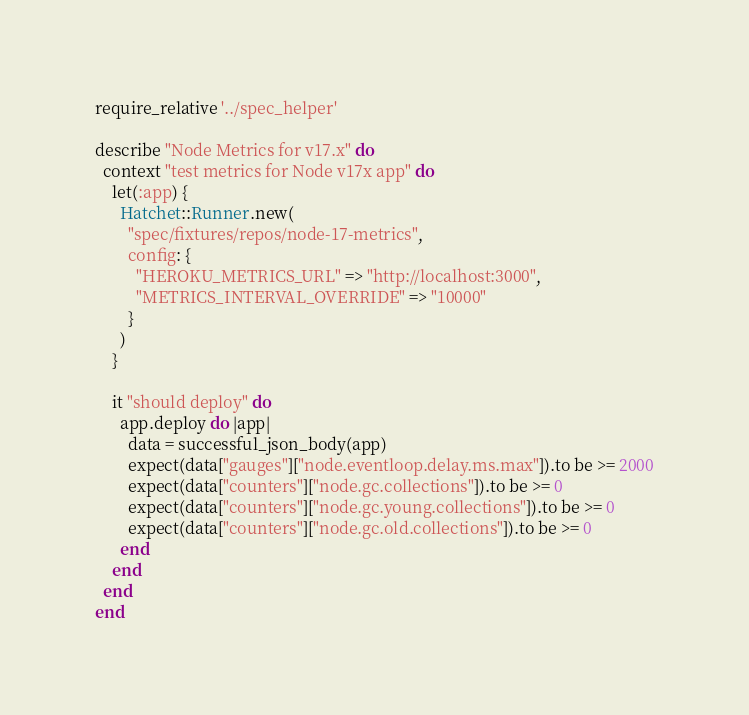Convert code to text. <code><loc_0><loc_0><loc_500><loc_500><_Ruby_>require_relative '../spec_helper'

describe "Node Metrics for v17.x" do
  context "test metrics for Node v17x app" do
    let(:app) {
      Hatchet::Runner.new(
        "spec/fixtures/repos/node-17-metrics",
        config: {
          "HEROKU_METRICS_URL" => "http://localhost:3000",
          "METRICS_INTERVAL_OVERRIDE" => "10000"
        }
      )
    }

    it "should deploy" do
      app.deploy do |app|
        data = successful_json_body(app)
        expect(data["gauges"]["node.eventloop.delay.ms.max"]).to be >= 2000
        expect(data["counters"]["node.gc.collections"]).to be >= 0
        expect(data["counters"]["node.gc.young.collections"]).to be >= 0
        expect(data["counters"]["node.gc.old.collections"]).to be >= 0
      end
    end
  end
end
</code> 